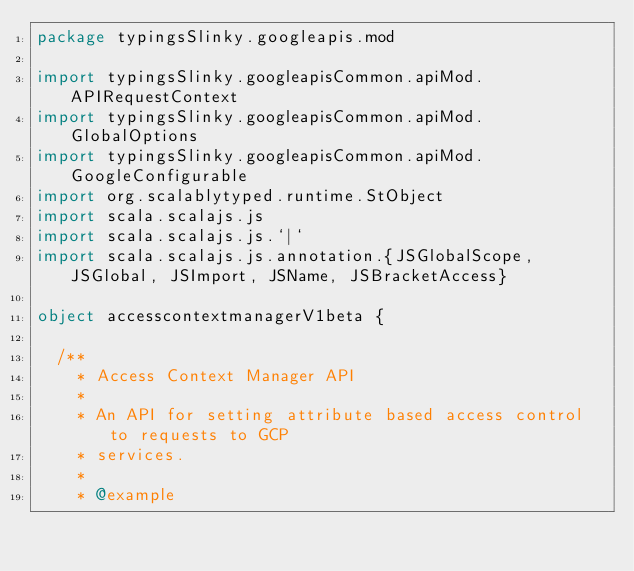<code> <loc_0><loc_0><loc_500><loc_500><_Scala_>package typingsSlinky.googleapis.mod

import typingsSlinky.googleapisCommon.apiMod.APIRequestContext
import typingsSlinky.googleapisCommon.apiMod.GlobalOptions
import typingsSlinky.googleapisCommon.apiMod.GoogleConfigurable
import org.scalablytyped.runtime.StObject
import scala.scalajs.js
import scala.scalajs.js.`|`
import scala.scalajs.js.annotation.{JSGlobalScope, JSGlobal, JSImport, JSName, JSBracketAccess}

object accesscontextmanagerV1beta {
  
  /**
    * Access Context Manager API
    *
    * An API for setting attribute based access control to requests to GCP
    * services.
    *
    * @example</code> 